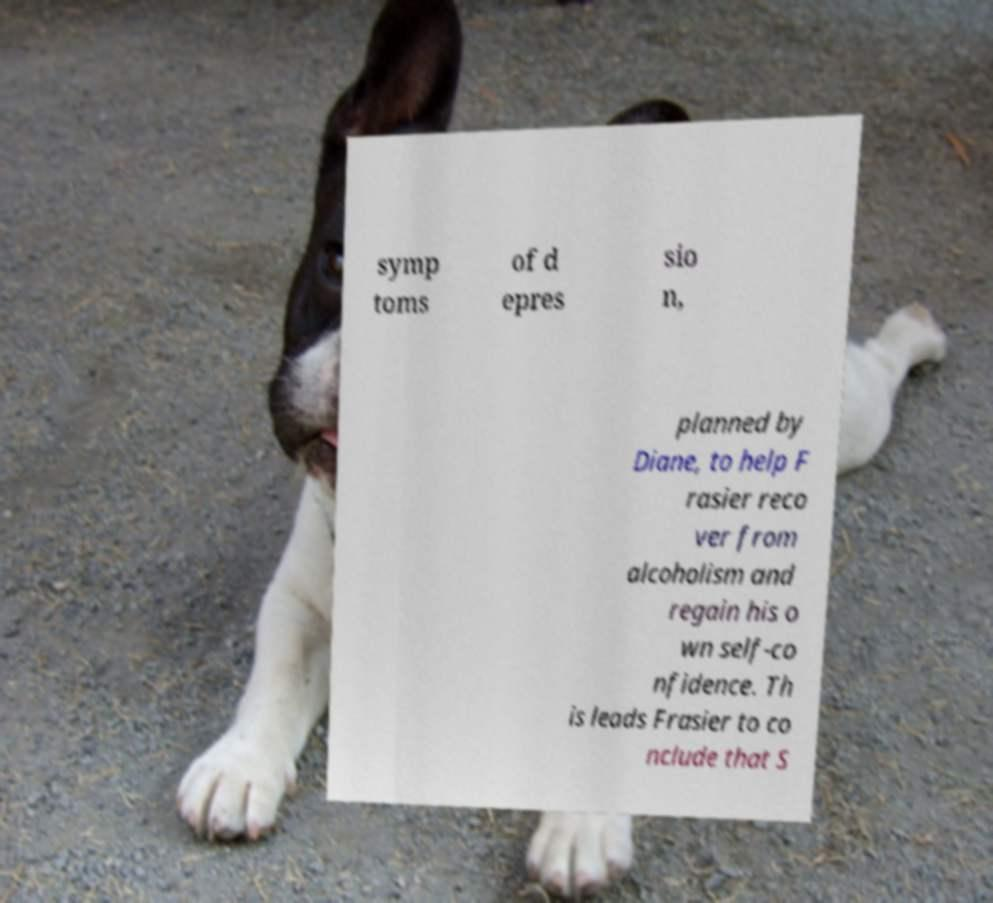I need the written content from this picture converted into text. Can you do that? symp toms of d epres sio n, planned by Diane, to help F rasier reco ver from alcoholism and regain his o wn self-co nfidence. Th is leads Frasier to co nclude that S 